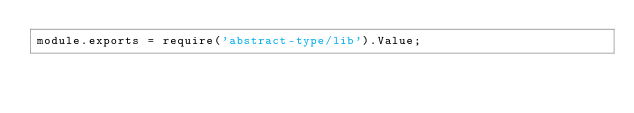<code> <loc_0><loc_0><loc_500><loc_500><_JavaScript_>module.exports = require('abstract-type/lib').Value;
</code> 